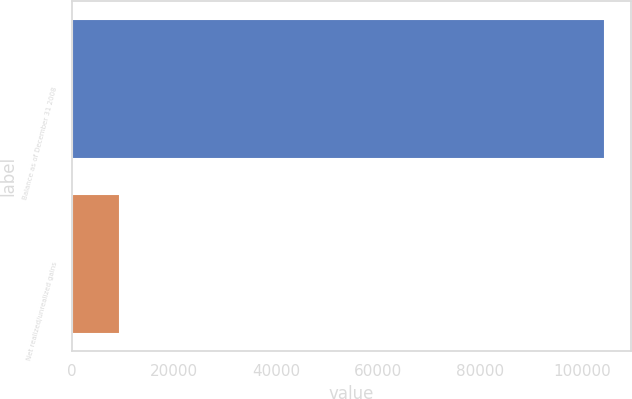<chart> <loc_0><loc_0><loc_500><loc_500><bar_chart><fcel>Balance as of December 31 2008<fcel>Net realized/unrealized gains<nl><fcel>104356<fcel>9535<nl></chart> 